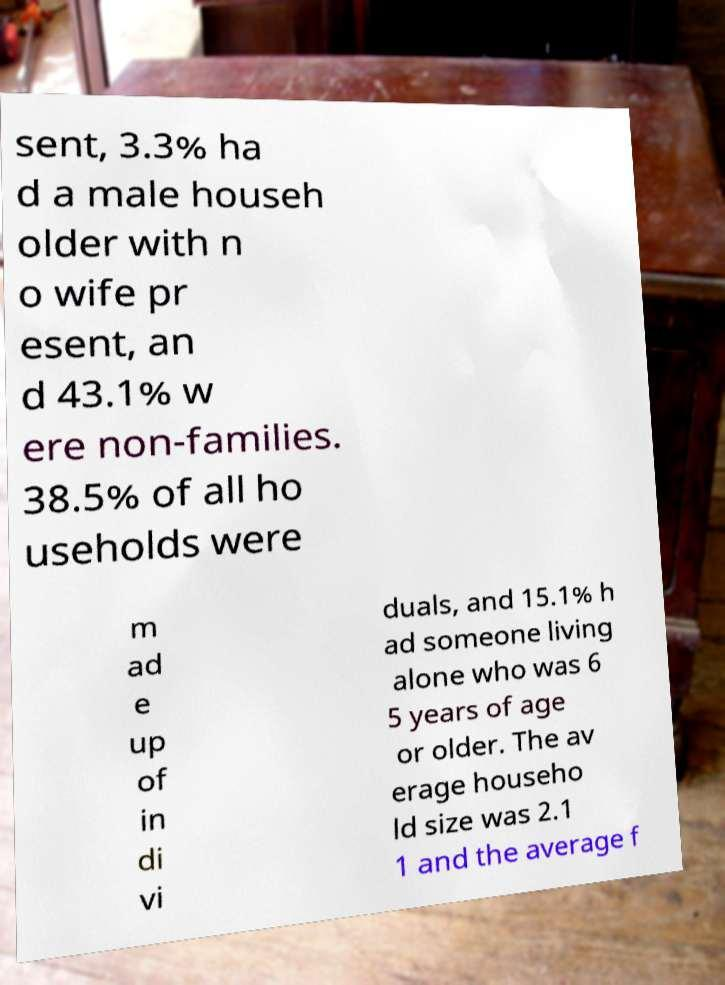Can you accurately transcribe the text from the provided image for me? sent, 3.3% ha d a male househ older with n o wife pr esent, an d 43.1% w ere non-families. 38.5% of all ho useholds were m ad e up of in di vi duals, and 15.1% h ad someone living alone who was 6 5 years of age or older. The av erage househo ld size was 2.1 1 and the average f 